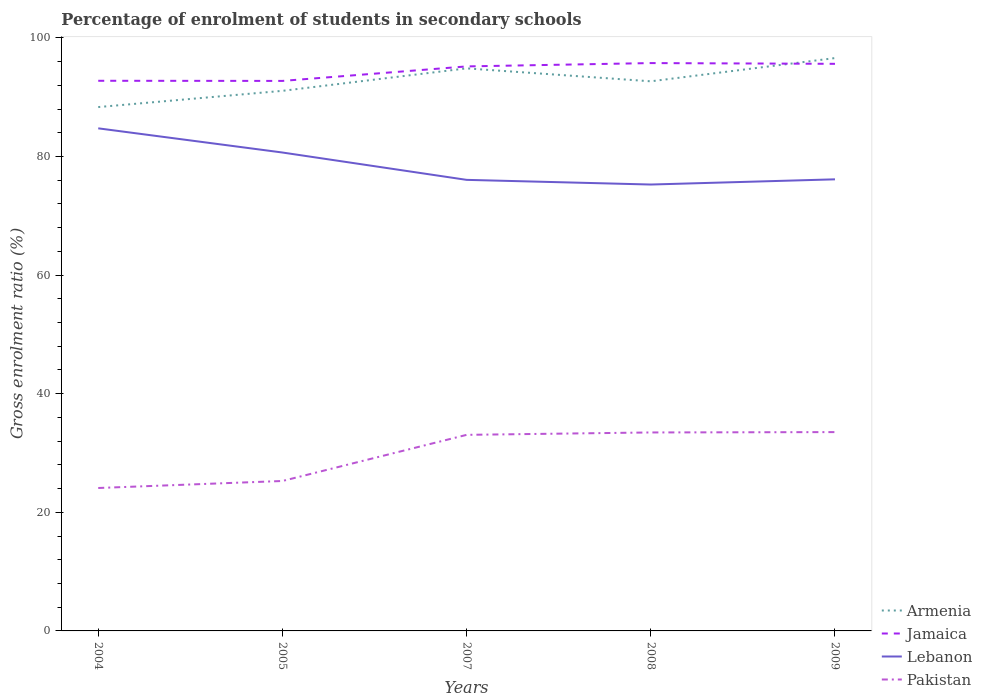Does the line corresponding to Lebanon intersect with the line corresponding to Jamaica?
Your answer should be very brief. No. Across all years, what is the maximum percentage of students enrolled in secondary schools in Pakistan?
Offer a terse response. 24.1. What is the total percentage of students enrolled in secondary schools in Lebanon in the graph?
Offer a terse response. 8.69. What is the difference between the highest and the second highest percentage of students enrolled in secondary schools in Jamaica?
Provide a short and direct response. 3.01. How many years are there in the graph?
Give a very brief answer. 5. What is the difference between two consecutive major ticks on the Y-axis?
Provide a succinct answer. 20. Are the values on the major ticks of Y-axis written in scientific E-notation?
Offer a very short reply. No. Does the graph contain any zero values?
Your answer should be very brief. No. Where does the legend appear in the graph?
Your answer should be compact. Bottom right. How many legend labels are there?
Give a very brief answer. 4. How are the legend labels stacked?
Offer a terse response. Vertical. What is the title of the graph?
Provide a short and direct response. Percentage of enrolment of students in secondary schools. Does "Euro area" appear as one of the legend labels in the graph?
Your answer should be compact. No. What is the Gross enrolment ratio (%) in Armenia in 2004?
Provide a short and direct response. 88.33. What is the Gross enrolment ratio (%) of Jamaica in 2004?
Offer a terse response. 92.76. What is the Gross enrolment ratio (%) of Lebanon in 2004?
Your answer should be very brief. 84.74. What is the Gross enrolment ratio (%) in Pakistan in 2004?
Provide a short and direct response. 24.1. What is the Gross enrolment ratio (%) of Armenia in 2005?
Offer a terse response. 91.07. What is the Gross enrolment ratio (%) of Jamaica in 2005?
Give a very brief answer. 92.74. What is the Gross enrolment ratio (%) in Lebanon in 2005?
Keep it short and to the point. 80.67. What is the Gross enrolment ratio (%) of Pakistan in 2005?
Provide a short and direct response. 25.28. What is the Gross enrolment ratio (%) in Armenia in 2007?
Your response must be concise. 94.85. What is the Gross enrolment ratio (%) in Jamaica in 2007?
Your answer should be very brief. 95.18. What is the Gross enrolment ratio (%) in Lebanon in 2007?
Provide a succinct answer. 76.06. What is the Gross enrolment ratio (%) of Pakistan in 2007?
Provide a succinct answer. 33.06. What is the Gross enrolment ratio (%) in Armenia in 2008?
Make the answer very short. 92.67. What is the Gross enrolment ratio (%) of Jamaica in 2008?
Keep it short and to the point. 95.75. What is the Gross enrolment ratio (%) in Lebanon in 2008?
Ensure brevity in your answer.  75.27. What is the Gross enrolment ratio (%) of Pakistan in 2008?
Provide a succinct answer. 33.46. What is the Gross enrolment ratio (%) of Armenia in 2009?
Keep it short and to the point. 96.59. What is the Gross enrolment ratio (%) in Jamaica in 2009?
Provide a short and direct response. 95.62. What is the Gross enrolment ratio (%) in Lebanon in 2009?
Give a very brief answer. 76.14. What is the Gross enrolment ratio (%) in Pakistan in 2009?
Keep it short and to the point. 33.52. Across all years, what is the maximum Gross enrolment ratio (%) in Armenia?
Provide a succinct answer. 96.59. Across all years, what is the maximum Gross enrolment ratio (%) in Jamaica?
Offer a terse response. 95.75. Across all years, what is the maximum Gross enrolment ratio (%) in Lebanon?
Offer a very short reply. 84.74. Across all years, what is the maximum Gross enrolment ratio (%) of Pakistan?
Keep it short and to the point. 33.52. Across all years, what is the minimum Gross enrolment ratio (%) in Armenia?
Make the answer very short. 88.33. Across all years, what is the minimum Gross enrolment ratio (%) in Jamaica?
Ensure brevity in your answer.  92.74. Across all years, what is the minimum Gross enrolment ratio (%) in Lebanon?
Offer a very short reply. 75.27. Across all years, what is the minimum Gross enrolment ratio (%) in Pakistan?
Offer a terse response. 24.1. What is the total Gross enrolment ratio (%) of Armenia in the graph?
Your response must be concise. 463.51. What is the total Gross enrolment ratio (%) in Jamaica in the graph?
Offer a terse response. 472.05. What is the total Gross enrolment ratio (%) in Lebanon in the graph?
Make the answer very short. 392.88. What is the total Gross enrolment ratio (%) of Pakistan in the graph?
Provide a succinct answer. 149.43. What is the difference between the Gross enrolment ratio (%) of Armenia in 2004 and that in 2005?
Ensure brevity in your answer.  -2.74. What is the difference between the Gross enrolment ratio (%) of Jamaica in 2004 and that in 2005?
Offer a terse response. 0.02. What is the difference between the Gross enrolment ratio (%) in Lebanon in 2004 and that in 2005?
Keep it short and to the point. 4.08. What is the difference between the Gross enrolment ratio (%) of Pakistan in 2004 and that in 2005?
Ensure brevity in your answer.  -1.18. What is the difference between the Gross enrolment ratio (%) of Armenia in 2004 and that in 2007?
Ensure brevity in your answer.  -6.53. What is the difference between the Gross enrolment ratio (%) in Jamaica in 2004 and that in 2007?
Make the answer very short. -2.42. What is the difference between the Gross enrolment ratio (%) in Lebanon in 2004 and that in 2007?
Give a very brief answer. 8.69. What is the difference between the Gross enrolment ratio (%) of Pakistan in 2004 and that in 2007?
Your answer should be very brief. -8.96. What is the difference between the Gross enrolment ratio (%) of Armenia in 2004 and that in 2008?
Ensure brevity in your answer.  -4.34. What is the difference between the Gross enrolment ratio (%) in Jamaica in 2004 and that in 2008?
Offer a terse response. -2.98. What is the difference between the Gross enrolment ratio (%) of Lebanon in 2004 and that in 2008?
Your response must be concise. 9.48. What is the difference between the Gross enrolment ratio (%) of Pakistan in 2004 and that in 2008?
Offer a terse response. -9.37. What is the difference between the Gross enrolment ratio (%) of Armenia in 2004 and that in 2009?
Your answer should be compact. -8.26. What is the difference between the Gross enrolment ratio (%) in Jamaica in 2004 and that in 2009?
Offer a terse response. -2.86. What is the difference between the Gross enrolment ratio (%) in Lebanon in 2004 and that in 2009?
Provide a short and direct response. 8.6. What is the difference between the Gross enrolment ratio (%) in Pakistan in 2004 and that in 2009?
Offer a very short reply. -9.43. What is the difference between the Gross enrolment ratio (%) of Armenia in 2005 and that in 2007?
Ensure brevity in your answer.  -3.79. What is the difference between the Gross enrolment ratio (%) in Jamaica in 2005 and that in 2007?
Make the answer very short. -2.45. What is the difference between the Gross enrolment ratio (%) in Lebanon in 2005 and that in 2007?
Offer a terse response. 4.61. What is the difference between the Gross enrolment ratio (%) of Pakistan in 2005 and that in 2007?
Ensure brevity in your answer.  -7.78. What is the difference between the Gross enrolment ratio (%) in Armenia in 2005 and that in 2008?
Your answer should be very brief. -1.61. What is the difference between the Gross enrolment ratio (%) in Jamaica in 2005 and that in 2008?
Offer a terse response. -3.01. What is the difference between the Gross enrolment ratio (%) in Lebanon in 2005 and that in 2008?
Give a very brief answer. 5.4. What is the difference between the Gross enrolment ratio (%) in Pakistan in 2005 and that in 2008?
Your response must be concise. -8.18. What is the difference between the Gross enrolment ratio (%) in Armenia in 2005 and that in 2009?
Your response must be concise. -5.53. What is the difference between the Gross enrolment ratio (%) of Jamaica in 2005 and that in 2009?
Offer a terse response. -2.88. What is the difference between the Gross enrolment ratio (%) of Lebanon in 2005 and that in 2009?
Offer a very short reply. 4.52. What is the difference between the Gross enrolment ratio (%) in Pakistan in 2005 and that in 2009?
Keep it short and to the point. -8.24. What is the difference between the Gross enrolment ratio (%) in Armenia in 2007 and that in 2008?
Your response must be concise. 2.18. What is the difference between the Gross enrolment ratio (%) of Jamaica in 2007 and that in 2008?
Provide a succinct answer. -0.56. What is the difference between the Gross enrolment ratio (%) of Lebanon in 2007 and that in 2008?
Keep it short and to the point. 0.79. What is the difference between the Gross enrolment ratio (%) in Pakistan in 2007 and that in 2008?
Offer a very short reply. -0.4. What is the difference between the Gross enrolment ratio (%) in Armenia in 2007 and that in 2009?
Ensure brevity in your answer.  -1.74. What is the difference between the Gross enrolment ratio (%) in Jamaica in 2007 and that in 2009?
Offer a terse response. -0.43. What is the difference between the Gross enrolment ratio (%) of Lebanon in 2007 and that in 2009?
Your answer should be compact. -0.09. What is the difference between the Gross enrolment ratio (%) in Pakistan in 2007 and that in 2009?
Offer a very short reply. -0.46. What is the difference between the Gross enrolment ratio (%) of Armenia in 2008 and that in 2009?
Provide a succinct answer. -3.92. What is the difference between the Gross enrolment ratio (%) in Jamaica in 2008 and that in 2009?
Your response must be concise. 0.13. What is the difference between the Gross enrolment ratio (%) in Lebanon in 2008 and that in 2009?
Offer a terse response. -0.88. What is the difference between the Gross enrolment ratio (%) of Pakistan in 2008 and that in 2009?
Your answer should be compact. -0.06. What is the difference between the Gross enrolment ratio (%) in Armenia in 2004 and the Gross enrolment ratio (%) in Jamaica in 2005?
Your answer should be very brief. -4.41. What is the difference between the Gross enrolment ratio (%) of Armenia in 2004 and the Gross enrolment ratio (%) of Lebanon in 2005?
Your answer should be very brief. 7.66. What is the difference between the Gross enrolment ratio (%) in Armenia in 2004 and the Gross enrolment ratio (%) in Pakistan in 2005?
Give a very brief answer. 63.05. What is the difference between the Gross enrolment ratio (%) in Jamaica in 2004 and the Gross enrolment ratio (%) in Lebanon in 2005?
Offer a very short reply. 12.1. What is the difference between the Gross enrolment ratio (%) in Jamaica in 2004 and the Gross enrolment ratio (%) in Pakistan in 2005?
Offer a very short reply. 67.48. What is the difference between the Gross enrolment ratio (%) of Lebanon in 2004 and the Gross enrolment ratio (%) of Pakistan in 2005?
Your response must be concise. 59.46. What is the difference between the Gross enrolment ratio (%) in Armenia in 2004 and the Gross enrolment ratio (%) in Jamaica in 2007?
Your response must be concise. -6.86. What is the difference between the Gross enrolment ratio (%) in Armenia in 2004 and the Gross enrolment ratio (%) in Lebanon in 2007?
Keep it short and to the point. 12.27. What is the difference between the Gross enrolment ratio (%) of Armenia in 2004 and the Gross enrolment ratio (%) of Pakistan in 2007?
Make the answer very short. 55.27. What is the difference between the Gross enrolment ratio (%) in Jamaica in 2004 and the Gross enrolment ratio (%) in Lebanon in 2007?
Offer a very short reply. 16.71. What is the difference between the Gross enrolment ratio (%) of Jamaica in 2004 and the Gross enrolment ratio (%) of Pakistan in 2007?
Keep it short and to the point. 59.7. What is the difference between the Gross enrolment ratio (%) in Lebanon in 2004 and the Gross enrolment ratio (%) in Pakistan in 2007?
Give a very brief answer. 51.68. What is the difference between the Gross enrolment ratio (%) of Armenia in 2004 and the Gross enrolment ratio (%) of Jamaica in 2008?
Make the answer very short. -7.42. What is the difference between the Gross enrolment ratio (%) in Armenia in 2004 and the Gross enrolment ratio (%) in Lebanon in 2008?
Your answer should be compact. 13.06. What is the difference between the Gross enrolment ratio (%) of Armenia in 2004 and the Gross enrolment ratio (%) of Pakistan in 2008?
Give a very brief answer. 54.86. What is the difference between the Gross enrolment ratio (%) in Jamaica in 2004 and the Gross enrolment ratio (%) in Lebanon in 2008?
Ensure brevity in your answer.  17.5. What is the difference between the Gross enrolment ratio (%) in Jamaica in 2004 and the Gross enrolment ratio (%) in Pakistan in 2008?
Give a very brief answer. 59.3. What is the difference between the Gross enrolment ratio (%) of Lebanon in 2004 and the Gross enrolment ratio (%) of Pakistan in 2008?
Provide a short and direct response. 51.28. What is the difference between the Gross enrolment ratio (%) of Armenia in 2004 and the Gross enrolment ratio (%) of Jamaica in 2009?
Provide a short and direct response. -7.29. What is the difference between the Gross enrolment ratio (%) of Armenia in 2004 and the Gross enrolment ratio (%) of Lebanon in 2009?
Provide a short and direct response. 12.18. What is the difference between the Gross enrolment ratio (%) in Armenia in 2004 and the Gross enrolment ratio (%) in Pakistan in 2009?
Provide a succinct answer. 54.8. What is the difference between the Gross enrolment ratio (%) in Jamaica in 2004 and the Gross enrolment ratio (%) in Lebanon in 2009?
Offer a terse response. 16.62. What is the difference between the Gross enrolment ratio (%) of Jamaica in 2004 and the Gross enrolment ratio (%) of Pakistan in 2009?
Your response must be concise. 59.24. What is the difference between the Gross enrolment ratio (%) of Lebanon in 2004 and the Gross enrolment ratio (%) of Pakistan in 2009?
Give a very brief answer. 51.22. What is the difference between the Gross enrolment ratio (%) in Armenia in 2005 and the Gross enrolment ratio (%) in Jamaica in 2007?
Offer a terse response. -4.12. What is the difference between the Gross enrolment ratio (%) in Armenia in 2005 and the Gross enrolment ratio (%) in Lebanon in 2007?
Provide a short and direct response. 15.01. What is the difference between the Gross enrolment ratio (%) of Armenia in 2005 and the Gross enrolment ratio (%) of Pakistan in 2007?
Offer a very short reply. 58.01. What is the difference between the Gross enrolment ratio (%) in Jamaica in 2005 and the Gross enrolment ratio (%) in Lebanon in 2007?
Provide a succinct answer. 16.68. What is the difference between the Gross enrolment ratio (%) of Jamaica in 2005 and the Gross enrolment ratio (%) of Pakistan in 2007?
Ensure brevity in your answer.  59.68. What is the difference between the Gross enrolment ratio (%) of Lebanon in 2005 and the Gross enrolment ratio (%) of Pakistan in 2007?
Your response must be concise. 47.61. What is the difference between the Gross enrolment ratio (%) of Armenia in 2005 and the Gross enrolment ratio (%) of Jamaica in 2008?
Ensure brevity in your answer.  -4.68. What is the difference between the Gross enrolment ratio (%) in Armenia in 2005 and the Gross enrolment ratio (%) in Lebanon in 2008?
Your response must be concise. 15.8. What is the difference between the Gross enrolment ratio (%) of Armenia in 2005 and the Gross enrolment ratio (%) of Pakistan in 2008?
Give a very brief answer. 57.6. What is the difference between the Gross enrolment ratio (%) in Jamaica in 2005 and the Gross enrolment ratio (%) in Lebanon in 2008?
Offer a terse response. 17.47. What is the difference between the Gross enrolment ratio (%) of Jamaica in 2005 and the Gross enrolment ratio (%) of Pakistan in 2008?
Keep it short and to the point. 59.27. What is the difference between the Gross enrolment ratio (%) in Lebanon in 2005 and the Gross enrolment ratio (%) in Pakistan in 2008?
Give a very brief answer. 47.2. What is the difference between the Gross enrolment ratio (%) of Armenia in 2005 and the Gross enrolment ratio (%) of Jamaica in 2009?
Offer a terse response. -4.55. What is the difference between the Gross enrolment ratio (%) of Armenia in 2005 and the Gross enrolment ratio (%) of Lebanon in 2009?
Offer a terse response. 14.92. What is the difference between the Gross enrolment ratio (%) in Armenia in 2005 and the Gross enrolment ratio (%) in Pakistan in 2009?
Provide a short and direct response. 57.54. What is the difference between the Gross enrolment ratio (%) in Jamaica in 2005 and the Gross enrolment ratio (%) in Lebanon in 2009?
Provide a short and direct response. 16.59. What is the difference between the Gross enrolment ratio (%) in Jamaica in 2005 and the Gross enrolment ratio (%) in Pakistan in 2009?
Your answer should be compact. 59.22. What is the difference between the Gross enrolment ratio (%) of Lebanon in 2005 and the Gross enrolment ratio (%) of Pakistan in 2009?
Provide a succinct answer. 47.14. What is the difference between the Gross enrolment ratio (%) in Armenia in 2007 and the Gross enrolment ratio (%) in Jamaica in 2008?
Make the answer very short. -0.89. What is the difference between the Gross enrolment ratio (%) in Armenia in 2007 and the Gross enrolment ratio (%) in Lebanon in 2008?
Offer a terse response. 19.59. What is the difference between the Gross enrolment ratio (%) of Armenia in 2007 and the Gross enrolment ratio (%) of Pakistan in 2008?
Your response must be concise. 61.39. What is the difference between the Gross enrolment ratio (%) of Jamaica in 2007 and the Gross enrolment ratio (%) of Lebanon in 2008?
Your response must be concise. 19.92. What is the difference between the Gross enrolment ratio (%) in Jamaica in 2007 and the Gross enrolment ratio (%) in Pakistan in 2008?
Keep it short and to the point. 61.72. What is the difference between the Gross enrolment ratio (%) of Lebanon in 2007 and the Gross enrolment ratio (%) of Pakistan in 2008?
Provide a succinct answer. 42.59. What is the difference between the Gross enrolment ratio (%) in Armenia in 2007 and the Gross enrolment ratio (%) in Jamaica in 2009?
Keep it short and to the point. -0.76. What is the difference between the Gross enrolment ratio (%) in Armenia in 2007 and the Gross enrolment ratio (%) in Lebanon in 2009?
Offer a very short reply. 18.71. What is the difference between the Gross enrolment ratio (%) of Armenia in 2007 and the Gross enrolment ratio (%) of Pakistan in 2009?
Your answer should be very brief. 61.33. What is the difference between the Gross enrolment ratio (%) of Jamaica in 2007 and the Gross enrolment ratio (%) of Lebanon in 2009?
Give a very brief answer. 19.04. What is the difference between the Gross enrolment ratio (%) in Jamaica in 2007 and the Gross enrolment ratio (%) in Pakistan in 2009?
Your answer should be compact. 61.66. What is the difference between the Gross enrolment ratio (%) of Lebanon in 2007 and the Gross enrolment ratio (%) of Pakistan in 2009?
Provide a succinct answer. 42.53. What is the difference between the Gross enrolment ratio (%) of Armenia in 2008 and the Gross enrolment ratio (%) of Jamaica in 2009?
Keep it short and to the point. -2.95. What is the difference between the Gross enrolment ratio (%) in Armenia in 2008 and the Gross enrolment ratio (%) in Lebanon in 2009?
Give a very brief answer. 16.53. What is the difference between the Gross enrolment ratio (%) of Armenia in 2008 and the Gross enrolment ratio (%) of Pakistan in 2009?
Offer a very short reply. 59.15. What is the difference between the Gross enrolment ratio (%) in Jamaica in 2008 and the Gross enrolment ratio (%) in Lebanon in 2009?
Provide a succinct answer. 19.6. What is the difference between the Gross enrolment ratio (%) of Jamaica in 2008 and the Gross enrolment ratio (%) of Pakistan in 2009?
Provide a succinct answer. 62.22. What is the difference between the Gross enrolment ratio (%) of Lebanon in 2008 and the Gross enrolment ratio (%) of Pakistan in 2009?
Make the answer very short. 41.74. What is the average Gross enrolment ratio (%) in Armenia per year?
Keep it short and to the point. 92.7. What is the average Gross enrolment ratio (%) of Jamaica per year?
Keep it short and to the point. 94.41. What is the average Gross enrolment ratio (%) of Lebanon per year?
Ensure brevity in your answer.  78.58. What is the average Gross enrolment ratio (%) in Pakistan per year?
Your answer should be very brief. 29.89. In the year 2004, what is the difference between the Gross enrolment ratio (%) of Armenia and Gross enrolment ratio (%) of Jamaica?
Give a very brief answer. -4.43. In the year 2004, what is the difference between the Gross enrolment ratio (%) in Armenia and Gross enrolment ratio (%) in Lebanon?
Keep it short and to the point. 3.58. In the year 2004, what is the difference between the Gross enrolment ratio (%) of Armenia and Gross enrolment ratio (%) of Pakistan?
Give a very brief answer. 64.23. In the year 2004, what is the difference between the Gross enrolment ratio (%) of Jamaica and Gross enrolment ratio (%) of Lebanon?
Your answer should be very brief. 8.02. In the year 2004, what is the difference between the Gross enrolment ratio (%) in Jamaica and Gross enrolment ratio (%) in Pakistan?
Provide a short and direct response. 68.66. In the year 2004, what is the difference between the Gross enrolment ratio (%) in Lebanon and Gross enrolment ratio (%) in Pakistan?
Provide a succinct answer. 60.65. In the year 2005, what is the difference between the Gross enrolment ratio (%) in Armenia and Gross enrolment ratio (%) in Jamaica?
Offer a terse response. -1.67. In the year 2005, what is the difference between the Gross enrolment ratio (%) in Armenia and Gross enrolment ratio (%) in Lebanon?
Your answer should be very brief. 10.4. In the year 2005, what is the difference between the Gross enrolment ratio (%) of Armenia and Gross enrolment ratio (%) of Pakistan?
Keep it short and to the point. 65.78. In the year 2005, what is the difference between the Gross enrolment ratio (%) in Jamaica and Gross enrolment ratio (%) in Lebanon?
Your answer should be very brief. 12.07. In the year 2005, what is the difference between the Gross enrolment ratio (%) of Jamaica and Gross enrolment ratio (%) of Pakistan?
Provide a succinct answer. 67.46. In the year 2005, what is the difference between the Gross enrolment ratio (%) of Lebanon and Gross enrolment ratio (%) of Pakistan?
Provide a short and direct response. 55.39. In the year 2007, what is the difference between the Gross enrolment ratio (%) in Armenia and Gross enrolment ratio (%) in Jamaica?
Your answer should be very brief. -0.33. In the year 2007, what is the difference between the Gross enrolment ratio (%) in Armenia and Gross enrolment ratio (%) in Lebanon?
Give a very brief answer. 18.8. In the year 2007, what is the difference between the Gross enrolment ratio (%) of Armenia and Gross enrolment ratio (%) of Pakistan?
Ensure brevity in your answer.  61.79. In the year 2007, what is the difference between the Gross enrolment ratio (%) of Jamaica and Gross enrolment ratio (%) of Lebanon?
Provide a succinct answer. 19.13. In the year 2007, what is the difference between the Gross enrolment ratio (%) of Jamaica and Gross enrolment ratio (%) of Pakistan?
Offer a terse response. 62.12. In the year 2007, what is the difference between the Gross enrolment ratio (%) of Lebanon and Gross enrolment ratio (%) of Pakistan?
Your response must be concise. 43. In the year 2008, what is the difference between the Gross enrolment ratio (%) of Armenia and Gross enrolment ratio (%) of Jamaica?
Offer a very short reply. -3.07. In the year 2008, what is the difference between the Gross enrolment ratio (%) in Armenia and Gross enrolment ratio (%) in Lebanon?
Provide a short and direct response. 17.41. In the year 2008, what is the difference between the Gross enrolment ratio (%) of Armenia and Gross enrolment ratio (%) of Pakistan?
Provide a succinct answer. 59.21. In the year 2008, what is the difference between the Gross enrolment ratio (%) of Jamaica and Gross enrolment ratio (%) of Lebanon?
Make the answer very short. 20.48. In the year 2008, what is the difference between the Gross enrolment ratio (%) of Jamaica and Gross enrolment ratio (%) of Pakistan?
Ensure brevity in your answer.  62.28. In the year 2008, what is the difference between the Gross enrolment ratio (%) of Lebanon and Gross enrolment ratio (%) of Pakistan?
Make the answer very short. 41.8. In the year 2009, what is the difference between the Gross enrolment ratio (%) of Armenia and Gross enrolment ratio (%) of Jamaica?
Provide a succinct answer. 0.97. In the year 2009, what is the difference between the Gross enrolment ratio (%) in Armenia and Gross enrolment ratio (%) in Lebanon?
Your answer should be very brief. 20.45. In the year 2009, what is the difference between the Gross enrolment ratio (%) in Armenia and Gross enrolment ratio (%) in Pakistan?
Offer a very short reply. 63.07. In the year 2009, what is the difference between the Gross enrolment ratio (%) in Jamaica and Gross enrolment ratio (%) in Lebanon?
Provide a short and direct response. 19.48. In the year 2009, what is the difference between the Gross enrolment ratio (%) of Jamaica and Gross enrolment ratio (%) of Pakistan?
Keep it short and to the point. 62.1. In the year 2009, what is the difference between the Gross enrolment ratio (%) in Lebanon and Gross enrolment ratio (%) in Pakistan?
Offer a very short reply. 42.62. What is the ratio of the Gross enrolment ratio (%) in Armenia in 2004 to that in 2005?
Offer a terse response. 0.97. What is the ratio of the Gross enrolment ratio (%) in Lebanon in 2004 to that in 2005?
Offer a very short reply. 1.05. What is the ratio of the Gross enrolment ratio (%) in Pakistan in 2004 to that in 2005?
Offer a very short reply. 0.95. What is the ratio of the Gross enrolment ratio (%) of Armenia in 2004 to that in 2007?
Give a very brief answer. 0.93. What is the ratio of the Gross enrolment ratio (%) in Jamaica in 2004 to that in 2007?
Your answer should be very brief. 0.97. What is the ratio of the Gross enrolment ratio (%) of Lebanon in 2004 to that in 2007?
Offer a very short reply. 1.11. What is the ratio of the Gross enrolment ratio (%) in Pakistan in 2004 to that in 2007?
Your response must be concise. 0.73. What is the ratio of the Gross enrolment ratio (%) in Armenia in 2004 to that in 2008?
Give a very brief answer. 0.95. What is the ratio of the Gross enrolment ratio (%) of Jamaica in 2004 to that in 2008?
Offer a terse response. 0.97. What is the ratio of the Gross enrolment ratio (%) of Lebanon in 2004 to that in 2008?
Offer a very short reply. 1.13. What is the ratio of the Gross enrolment ratio (%) of Pakistan in 2004 to that in 2008?
Provide a succinct answer. 0.72. What is the ratio of the Gross enrolment ratio (%) of Armenia in 2004 to that in 2009?
Your answer should be very brief. 0.91. What is the ratio of the Gross enrolment ratio (%) in Jamaica in 2004 to that in 2009?
Provide a short and direct response. 0.97. What is the ratio of the Gross enrolment ratio (%) of Lebanon in 2004 to that in 2009?
Offer a terse response. 1.11. What is the ratio of the Gross enrolment ratio (%) in Pakistan in 2004 to that in 2009?
Offer a terse response. 0.72. What is the ratio of the Gross enrolment ratio (%) of Jamaica in 2005 to that in 2007?
Your answer should be very brief. 0.97. What is the ratio of the Gross enrolment ratio (%) in Lebanon in 2005 to that in 2007?
Your answer should be very brief. 1.06. What is the ratio of the Gross enrolment ratio (%) of Pakistan in 2005 to that in 2007?
Your answer should be compact. 0.76. What is the ratio of the Gross enrolment ratio (%) of Armenia in 2005 to that in 2008?
Make the answer very short. 0.98. What is the ratio of the Gross enrolment ratio (%) in Jamaica in 2005 to that in 2008?
Provide a short and direct response. 0.97. What is the ratio of the Gross enrolment ratio (%) of Lebanon in 2005 to that in 2008?
Your answer should be compact. 1.07. What is the ratio of the Gross enrolment ratio (%) in Pakistan in 2005 to that in 2008?
Give a very brief answer. 0.76. What is the ratio of the Gross enrolment ratio (%) of Armenia in 2005 to that in 2009?
Make the answer very short. 0.94. What is the ratio of the Gross enrolment ratio (%) of Jamaica in 2005 to that in 2009?
Offer a very short reply. 0.97. What is the ratio of the Gross enrolment ratio (%) of Lebanon in 2005 to that in 2009?
Your answer should be compact. 1.06. What is the ratio of the Gross enrolment ratio (%) in Pakistan in 2005 to that in 2009?
Provide a succinct answer. 0.75. What is the ratio of the Gross enrolment ratio (%) in Armenia in 2007 to that in 2008?
Ensure brevity in your answer.  1.02. What is the ratio of the Gross enrolment ratio (%) of Jamaica in 2007 to that in 2008?
Your answer should be very brief. 0.99. What is the ratio of the Gross enrolment ratio (%) in Lebanon in 2007 to that in 2008?
Ensure brevity in your answer.  1.01. What is the ratio of the Gross enrolment ratio (%) in Pakistan in 2007 to that in 2008?
Offer a terse response. 0.99. What is the ratio of the Gross enrolment ratio (%) of Armenia in 2007 to that in 2009?
Offer a very short reply. 0.98. What is the ratio of the Gross enrolment ratio (%) of Pakistan in 2007 to that in 2009?
Keep it short and to the point. 0.99. What is the ratio of the Gross enrolment ratio (%) of Armenia in 2008 to that in 2009?
Your answer should be compact. 0.96. What is the ratio of the Gross enrolment ratio (%) of Jamaica in 2008 to that in 2009?
Make the answer very short. 1. What is the ratio of the Gross enrolment ratio (%) of Pakistan in 2008 to that in 2009?
Make the answer very short. 1. What is the difference between the highest and the second highest Gross enrolment ratio (%) in Armenia?
Offer a terse response. 1.74. What is the difference between the highest and the second highest Gross enrolment ratio (%) in Jamaica?
Your answer should be compact. 0.13. What is the difference between the highest and the second highest Gross enrolment ratio (%) of Lebanon?
Offer a terse response. 4.08. What is the difference between the highest and the second highest Gross enrolment ratio (%) of Pakistan?
Provide a succinct answer. 0.06. What is the difference between the highest and the lowest Gross enrolment ratio (%) of Armenia?
Offer a terse response. 8.26. What is the difference between the highest and the lowest Gross enrolment ratio (%) in Jamaica?
Give a very brief answer. 3.01. What is the difference between the highest and the lowest Gross enrolment ratio (%) in Lebanon?
Keep it short and to the point. 9.48. What is the difference between the highest and the lowest Gross enrolment ratio (%) in Pakistan?
Provide a succinct answer. 9.43. 